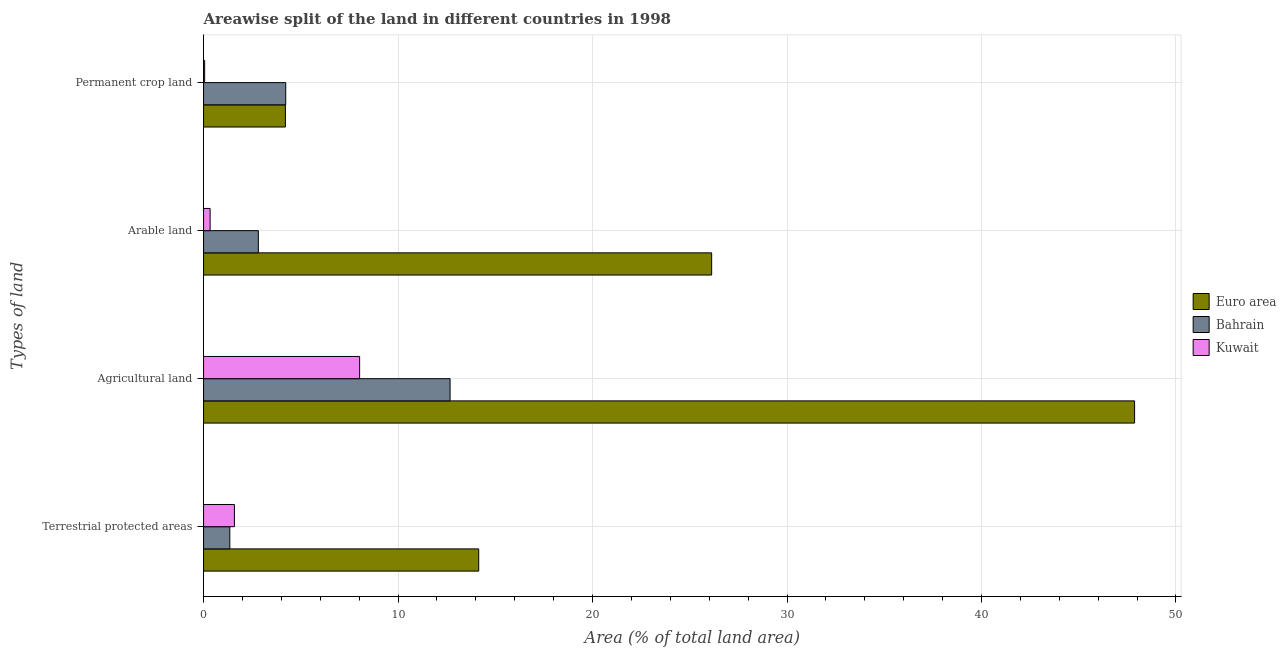How many groups of bars are there?
Keep it short and to the point. 4. Are the number of bars per tick equal to the number of legend labels?
Your answer should be compact. Yes. What is the label of the 1st group of bars from the top?
Provide a short and direct response. Permanent crop land. What is the percentage of area under permanent crop land in Bahrain?
Make the answer very short. 4.23. Across all countries, what is the maximum percentage of land under terrestrial protection?
Offer a terse response. 14.15. Across all countries, what is the minimum percentage of area under permanent crop land?
Provide a short and direct response. 0.06. In which country was the percentage of area under permanent crop land maximum?
Ensure brevity in your answer.  Bahrain. In which country was the percentage of area under arable land minimum?
Offer a terse response. Kuwait. What is the total percentage of area under permanent crop land in the graph?
Make the answer very short. 8.49. What is the difference between the percentage of land under terrestrial protection in Bahrain and that in Euro area?
Keep it short and to the point. -12.8. What is the difference between the percentage of land under terrestrial protection in Bahrain and the percentage of area under arable land in Kuwait?
Offer a terse response. 1.01. What is the average percentage of area under arable land per country?
Your answer should be very brief. 9.76. What is the difference between the percentage of area under arable land and percentage of area under permanent crop land in Bahrain?
Provide a succinct answer. -1.41. What is the ratio of the percentage of area under agricultural land in Kuwait to that in Bahrain?
Give a very brief answer. 0.63. What is the difference between the highest and the second highest percentage of area under permanent crop land?
Provide a short and direct response. 0.02. What is the difference between the highest and the lowest percentage of area under permanent crop land?
Your answer should be compact. 4.17. In how many countries, is the percentage of area under permanent crop land greater than the average percentage of area under permanent crop land taken over all countries?
Keep it short and to the point. 2. Is the sum of the percentage of land under terrestrial protection in Euro area and Kuwait greater than the maximum percentage of area under agricultural land across all countries?
Make the answer very short. No. Is it the case that in every country, the sum of the percentage of area under permanent crop land and percentage of area under agricultural land is greater than the sum of percentage of land under terrestrial protection and percentage of area under arable land?
Provide a short and direct response. No. What does the 3rd bar from the bottom in Terrestrial protected areas represents?
Provide a short and direct response. Kuwait. Is it the case that in every country, the sum of the percentage of land under terrestrial protection and percentage of area under agricultural land is greater than the percentage of area under arable land?
Provide a succinct answer. Yes. Are all the bars in the graph horizontal?
Offer a terse response. Yes. How many legend labels are there?
Your answer should be very brief. 3. What is the title of the graph?
Offer a very short reply. Areawise split of the land in different countries in 1998. What is the label or title of the X-axis?
Offer a very short reply. Area (% of total land area). What is the label or title of the Y-axis?
Ensure brevity in your answer.  Types of land. What is the Area (% of total land area) of Euro area in Terrestrial protected areas?
Provide a short and direct response. 14.15. What is the Area (% of total land area) in Bahrain in Terrestrial protected areas?
Ensure brevity in your answer.  1.35. What is the Area (% of total land area) in Kuwait in Terrestrial protected areas?
Keep it short and to the point. 1.59. What is the Area (% of total land area) of Euro area in Agricultural land?
Make the answer very short. 47.87. What is the Area (% of total land area) in Bahrain in Agricultural land?
Provide a short and direct response. 12.68. What is the Area (% of total land area) of Kuwait in Agricultural land?
Give a very brief answer. 8.02. What is the Area (% of total land area) of Euro area in Arable land?
Offer a terse response. 26.13. What is the Area (% of total land area) of Bahrain in Arable land?
Offer a terse response. 2.82. What is the Area (% of total land area) in Kuwait in Arable land?
Offer a very short reply. 0.34. What is the Area (% of total land area) of Euro area in Permanent crop land?
Make the answer very short. 4.21. What is the Area (% of total land area) in Bahrain in Permanent crop land?
Provide a short and direct response. 4.23. What is the Area (% of total land area) of Kuwait in Permanent crop land?
Your answer should be compact. 0.06. Across all Types of land, what is the maximum Area (% of total land area) in Euro area?
Give a very brief answer. 47.87. Across all Types of land, what is the maximum Area (% of total land area) in Bahrain?
Provide a short and direct response. 12.68. Across all Types of land, what is the maximum Area (% of total land area) of Kuwait?
Provide a succinct answer. 8.02. Across all Types of land, what is the minimum Area (% of total land area) in Euro area?
Provide a succinct answer. 4.21. Across all Types of land, what is the minimum Area (% of total land area) of Bahrain?
Provide a succinct answer. 1.35. Across all Types of land, what is the minimum Area (% of total land area) in Kuwait?
Offer a very short reply. 0.06. What is the total Area (% of total land area) of Euro area in the graph?
Your answer should be compact. 92.36. What is the total Area (% of total land area) of Bahrain in the graph?
Offer a terse response. 21.07. What is the total Area (% of total land area) in Kuwait in the graph?
Provide a short and direct response. 10. What is the difference between the Area (% of total land area) in Euro area in Terrestrial protected areas and that in Agricultural land?
Offer a terse response. -33.72. What is the difference between the Area (% of total land area) of Bahrain in Terrestrial protected areas and that in Agricultural land?
Your answer should be very brief. -11.33. What is the difference between the Area (% of total land area) of Kuwait in Terrestrial protected areas and that in Agricultural land?
Your answer should be very brief. -6.44. What is the difference between the Area (% of total land area) of Euro area in Terrestrial protected areas and that in Arable land?
Your response must be concise. -11.98. What is the difference between the Area (% of total land area) of Bahrain in Terrestrial protected areas and that in Arable land?
Your response must be concise. -1.47. What is the difference between the Area (% of total land area) in Kuwait in Terrestrial protected areas and that in Arable land?
Offer a very short reply. 1.25. What is the difference between the Area (% of total land area) of Euro area in Terrestrial protected areas and that in Permanent crop land?
Keep it short and to the point. 9.94. What is the difference between the Area (% of total land area) in Bahrain in Terrestrial protected areas and that in Permanent crop land?
Make the answer very short. -2.88. What is the difference between the Area (% of total land area) of Kuwait in Terrestrial protected areas and that in Permanent crop land?
Your response must be concise. 1.53. What is the difference between the Area (% of total land area) in Euro area in Agricultural land and that in Arable land?
Keep it short and to the point. 21.75. What is the difference between the Area (% of total land area) of Bahrain in Agricultural land and that in Arable land?
Provide a succinct answer. 9.86. What is the difference between the Area (% of total land area) in Kuwait in Agricultural land and that in Arable land?
Your answer should be compact. 7.69. What is the difference between the Area (% of total land area) of Euro area in Agricultural land and that in Permanent crop land?
Your answer should be very brief. 43.66. What is the difference between the Area (% of total land area) in Bahrain in Agricultural land and that in Permanent crop land?
Offer a terse response. 8.45. What is the difference between the Area (% of total land area) in Kuwait in Agricultural land and that in Permanent crop land?
Provide a short and direct response. 7.97. What is the difference between the Area (% of total land area) in Euro area in Arable land and that in Permanent crop land?
Offer a terse response. 21.92. What is the difference between the Area (% of total land area) of Bahrain in Arable land and that in Permanent crop land?
Your answer should be very brief. -1.41. What is the difference between the Area (% of total land area) in Kuwait in Arable land and that in Permanent crop land?
Give a very brief answer. 0.28. What is the difference between the Area (% of total land area) in Euro area in Terrestrial protected areas and the Area (% of total land area) in Bahrain in Agricultural land?
Your answer should be compact. 1.47. What is the difference between the Area (% of total land area) of Euro area in Terrestrial protected areas and the Area (% of total land area) of Kuwait in Agricultural land?
Provide a short and direct response. 6.12. What is the difference between the Area (% of total land area) of Bahrain in Terrestrial protected areas and the Area (% of total land area) of Kuwait in Agricultural land?
Your answer should be very brief. -6.67. What is the difference between the Area (% of total land area) in Euro area in Terrestrial protected areas and the Area (% of total land area) in Bahrain in Arable land?
Provide a short and direct response. 11.33. What is the difference between the Area (% of total land area) in Euro area in Terrestrial protected areas and the Area (% of total land area) in Kuwait in Arable land?
Your answer should be compact. 13.81. What is the difference between the Area (% of total land area) of Bahrain in Terrestrial protected areas and the Area (% of total land area) of Kuwait in Arable land?
Keep it short and to the point. 1.01. What is the difference between the Area (% of total land area) of Euro area in Terrestrial protected areas and the Area (% of total land area) of Bahrain in Permanent crop land?
Your answer should be compact. 9.92. What is the difference between the Area (% of total land area) in Euro area in Terrestrial protected areas and the Area (% of total land area) in Kuwait in Permanent crop land?
Your answer should be very brief. 14.09. What is the difference between the Area (% of total land area) in Bahrain in Terrestrial protected areas and the Area (% of total land area) in Kuwait in Permanent crop land?
Provide a short and direct response. 1.29. What is the difference between the Area (% of total land area) in Euro area in Agricultural land and the Area (% of total land area) in Bahrain in Arable land?
Provide a succinct answer. 45.06. What is the difference between the Area (% of total land area) of Euro area in Agricultural land and the Area (% of total land area) of Kuwait in Arable land?
Your answer should be compact. 47.54. What is the difference between the Area (% of total land area) of Bahrain in Agricultural land and the Area (% of total land area) of Kuwait in Arable land?
Offer a terse response. 12.34. What is the difference between the Area (% of total land area) of Euro area in Agricultural land and the Area (% of total land area) of Bahrain in Permanent crop land?
Your response must be concise. 43.65. What is the difference between the Area (% of total land area) of Euro area in Agricultural land and the Area (% of total land area) of Kuwait in Permanent crop land?
Make the answer very short. 47.82. What is the difference between the Area (% of total land area) in Bahrain in Agricultural land and the Area (% of total land area) in Kuwait in Permanent crop land?
Offer a terse response. 12.62. What is the difference between the Area (% of total land area) in Euro area in Arable land and the Area (% of total land area) in Bahrain in Permanent crop land?
Provide a short and direct response. 21.9. What is the difference between the Area (% of total land area) of Euro area in Arable land and the Area (% of total land area) of Kuwait in Permanent crop land?
Give a very brief answer. 26.07. What is the difference between the Area (% of total land area) of Bahrain in Arable land and the Area (% of total land area) of Kuwait in Permanent crop land?
Your answer should be very brief. 2.76. What is the average Area (% of total land area) in Euro area per Types of land?
Your answer should be compact. 23.09. What is the average Area (% of total land area) of Bahrain per Types of land?
Your answer should be very brief. 5.27. What is the average Area (% of total land area) in Kuwait per Types of land?
Give a very brief answer. 2.5. What is the difference between the Area (% of total land area) in Euro area and Area (% of total land area) in Bahrain in Terrestrial protected areas?
Your answer should be very brief. 12.8. What is the difference between the Area (% of total land area) of Euro area and Area (% of total land area) of Kuwait in Terrestrial protected areas?
Your answer should be compact. 12.56. What is the difference between the Area (% of total land area) of Bahrain and Area (% of total land area) of Kuwait in Terrestrial protected areas?
Your response must be concise. -0.24. What is the difference between the Area (% of total land area) in Euro area and Area (% of total land area) in Bahrain in Agricultural land?
Your answer should be very brief. 35.2. What is the difference between the Area (% of total land area) of Euro area and Area (% of total land area) of Kuwait in Agricultural land?
Offer a very short reply. 39.85. What is the difference between the Area (% of total land area) of Bahrain and Area (% of total land area) of Kuwait in Agricultural land?
Give a very brief answer. 4.65. What is the difference between the Area (% of total land area) in Euro area and Area (% of total land area) in Bahrain in Arable land?
Provide a succinct answer. 23.31. What is the difference between the Area (% of total land area) in Euro area and Area (% of total land area) in Kuwait in Arable land?
Your answer should be compact. 25.79. What is the difference between the Area (% of total land area) of Bahrain and Area (% of total land area) of Kuwait in Arable land?
Give a very brief answer. 2.48. What is the difference between the Area (% of total land area) of Euro area and Area (% of total land area) of Bahrain in Permanent crop land?
Provide a succinct answer. -0.02. What is the difference between the Area (% of total land area) in Euro area and Area (% of total land area) in Kuwait in Permanent crop land?
Your answer should be compact. 4.15. What is the difference between the Area (% of total land area) in Bahrain and Area (% of total land area) in Kuwait in Permanent crop land?
Offer a terse response. 4.17. What is the ratio of the Area (% of total land area) in Euro area in Terrestrial protected areas to that in Agricultural land?
Your answer should be very brief. 0.3. What is the ratio of the Area (% of total land area) of Bahrain in Terrestrial protected areas to that in Agricultural land?
Offer a very short reply. 0.11. What is the ratio of the Area (% of total land area) in Kuwait in Terrestrial protected areas to that in Agricultural land?
Ensure brevity in your answer.  0.2. What is the ratio of the Area (% of total land area) of Euro area in Terrestrial protected areas to that in Arable land?
Offer a terse response. 0.54. What is the ratio of the Area (% of total land area) in Bahrain in Terrestrial protected areas to that in Arable land?
Offer a terse response. 0.48. What is the ratio of the Area (% of total land area) of Kuwait in Terrestrial protected areas to that in Arable land?
Keep it short and to the point. 4.71. What is the ratio of the Area (% of total land area) of Euro area in Terrestrial protected areas to that in Permanent crop land?
Your answer should be very brief. 3.36. What is the ratio of the Area (% of total land area) in Bahrain in Terrestrial protected areas to that in Permanent crop land?
Offer a terse response. 0.32. What is the ratio of the Area (% of total land area) of Kuwait in Terrestrial protected areas to that in Permanent crop land?
Provide a succinct answer. 28.27. What is the ratio of the Area (% of total land area) of Euro area in Agricultural land to that in Arable land?
Offer a terse response. 1.83. What is the ratio of the Area (% of total land area) in Bahrain in Agricultural land to that in Arable land?
Offer a terse response. 4.5. What is the ratio of the Area (% of total land area) of Kuwait in Agricultural land to that in Arable land?
Keep it short and to the point. 23.83. What is the ratio of the Area (% of total land area) of Euro area in Agricultural land to that in Permanent crop land?
Ensure brevity in your answer.  11.38. What is the ratio of the Area (% of total land area) of Bahrain in Agricultural land to that in Permanent crop land?
Your answer should be compact. 3. What is the ratio of the Area (% of total land area) in Kuwait in Agricultural land to that in Permanent crop land?
Give a very brief answer. 143. What is the ratio of the Area (% of total land area) in Euro area in Arable land to that in Permanent crop land?
Provide a short and direct response. 6.21. What is the difference between the highest and the second highest Area (% of total land area) of Euro area?
Your answer should be very brief. 21.75. What is the difference between the highest and the second highest Area (% of total land area) of Bahrain?
Provide a short and direct response. 8.45. What is the difference between the highest and the second highest Area (% of total land area) in Kuwait?
Your response must be concise. 6.44. What is the difference between the highest and the lowest Area (% of total land area) in Euro area?
Your response must be concise. 43.66. What is the difference between the highest and the lowest Area (% of total land area) of Bahrain?
Offer a very short reply. 11.33. What is the difference between the highest and the lowest Area (% of total land area) of Kuwait?
Make the answer very short. 7.97. 